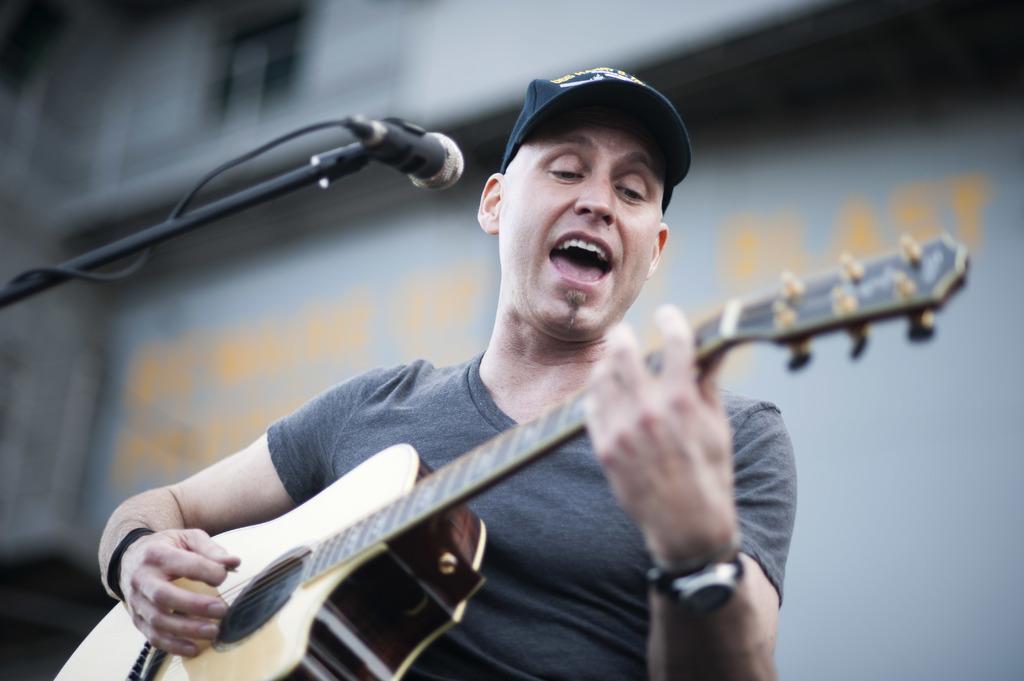Can you describe this image briefly? In this image we can see a man playing guitar and singing through the mic in front of him. 